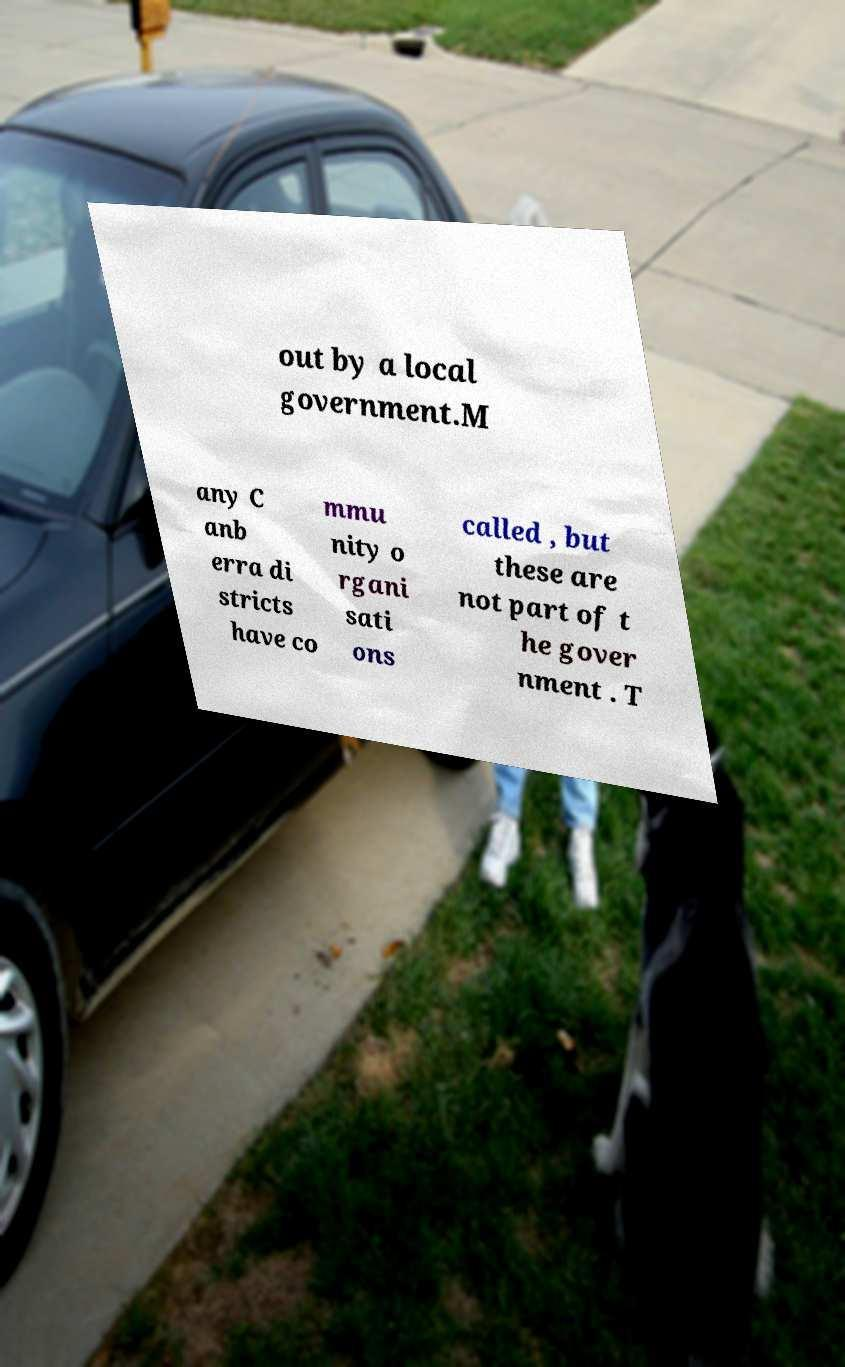There's text embedded in this image that I need extracted. Can you transcribe it verbatim? out by a local government.M any C anb erra di stricts have co mmu nity o rgani sati ons called , but these are not part of t he gover nment . T 